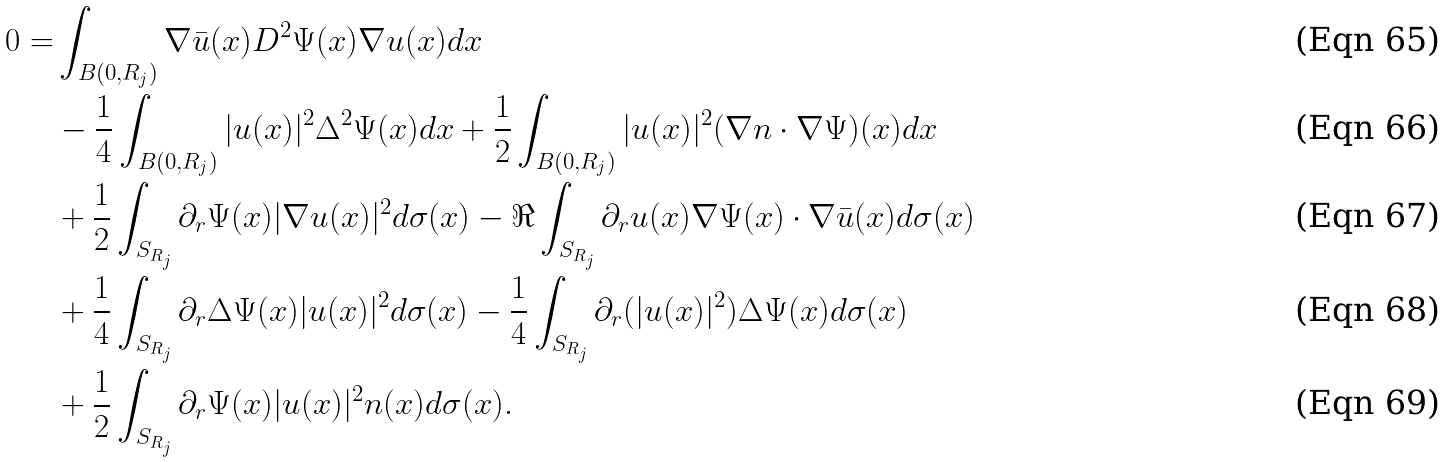<formula> <loc_0><loc_0><loc_500><loc_500>0 = & \int _ { B ( 0 , { R _ { j } } ) } { \nabla } \bar { u } ( x ) D ^ { 2 } \Psi ( x ) \nabla u ( x ) d x \\ & - \frac { 1 } { 4 } \int _ { B ( 0 , { R _ { j } } ) } | u ( x ) | ^ { 2 } { \Delta } ^ { 2 } \Psi ( x ) d x + \frac { 1 } { 2 } \int _ { B ( 0 , { R _ { j } } ) } | u ( x ) | ^ { 2 } ( \nabla n \cdot \nabla \Psi ) ( x ) d x \\ & + \frac { 1 } { 2 } \int _ { S _ { R _ { j } } } \partial _ { r } \Psi ( x ) | \nabla u ( x ) | ^ { 2 } d \sigma ( x ) - \Re \int _ { S _ { R _ { j } } } \partial _ { r } u ( x ) \nabla \Psi ( x ) \cdot \nabla \bar { u } ( x ) d \sigma ( x ) \\ & + \frac { 1 } { 4 } \int _ { S _ { R _ { j } } } \partial _ { r } \Delta \Psi ( x ) | u ( x ) | ^ { 2 } d \sigma ( x ) - \frac { 1 } { 4 } \int _ { S _ { R _ { j } } } \partial _ { r } ( | u ( x ) | ^ { 2 } ) \Delta \Psi ( x ) d \sigma ( x ) \\ & + \frac { 1 } { 2 } \int _ { S _ { R _ { j } } } \partial _ { r } \Psi ( x ) | u ( x ) | ^ { 2 } n ( x ) d \sigma ( x ) .</formula> 